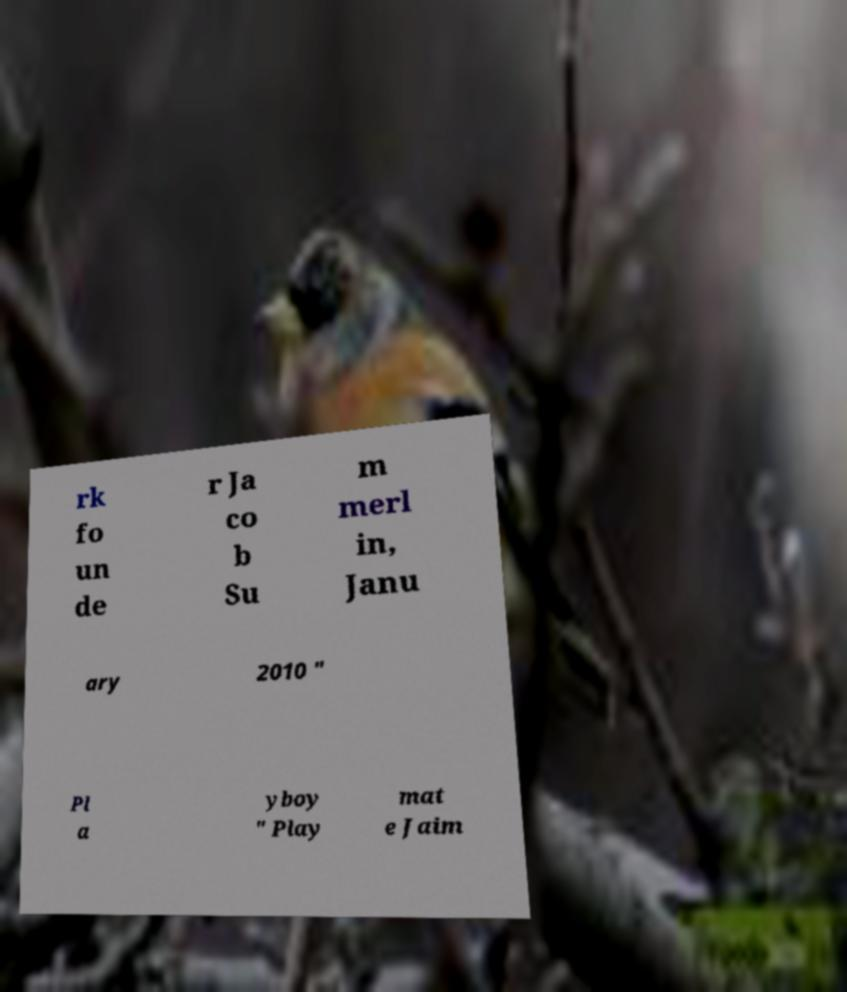I need the written content from this picture converted into text. Can you do that? rk fo un de r Ja co b Su m merl in, Janu ary 2010 " Pl a yboy " Play mat e Jaim 